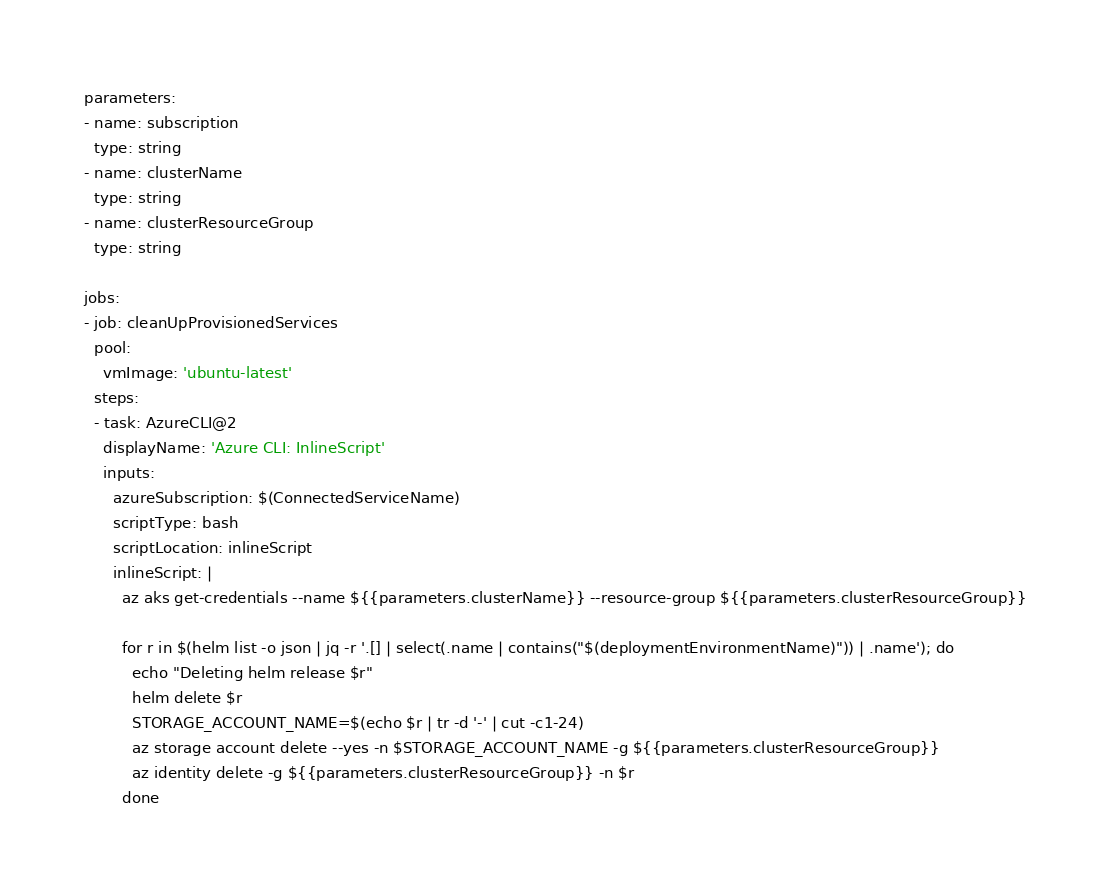<code> <loc_0><loc_0><loc_500><loc_500><_YAML_>
parameters:
- name: subscription
  type: string
- name: clusterName
  type: string
- name: clusterResourceGroup
  type: string

jobs:
- job: cleanUpProvisionedServices
  pool:
    vmImage: 'ubuntu-latest'
  steps:
  - task: AzureCLI@2
    displayName: 'Azure CLI: InlineScript'
    inputs:
      azureSubscription: $(ConnectedServiceName)
      scriptType: bash
      scriptLocation: inlineScript
      inlineScript: |
        az aks get-credentials --name ${{parameters.clusterName}} --resource-group ${{parameters.clusterResourceGroup}}

        for r in $(helm list -o json | jq -r '.[] | select(.name | contains("$(deploymentEnvironmentName)")) | .name'); do
          echo "Deleting helm release $r"
          helm delete $r
          STORAGE_ACCOUNT_NAME=$(echo $r | tr -d '-' | cut -c1-24)
          az storage account delete --yes -n $STORAGE_ACCOUNT_NAME -g ${{parameters.clusterResourceGroup}}
          az identity delete -g ${{parameters.clusterResourceGroup}} -n $r
        done
</code> 